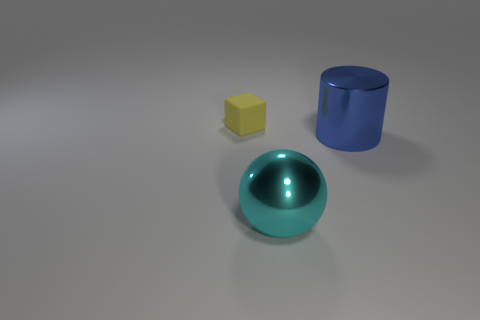What technological applications might utilize the geometric shapes shown in the image? The geometric shapes in the image can be associated with various technological applications. For example, the sphere can relate to technologies involving optics as spheres are often used in lenses. The cylinder could be related to fluid dynamics, useful in hydraulic systems, while the cube might be used in spatial design and 3D modeling software to help visualize and render spaces in architecture and gaming. Could these shapes be useful in educational software development? Absolutely, these shapes are fundamental in many educational software developments, especially in subjects like mathematics and physics. They help in visualizing and understanding 3D forms, aiding in practical exercises related to volume, area calculation, and understanding geometric properties, which are essential in a wide range of educational scenarios. 